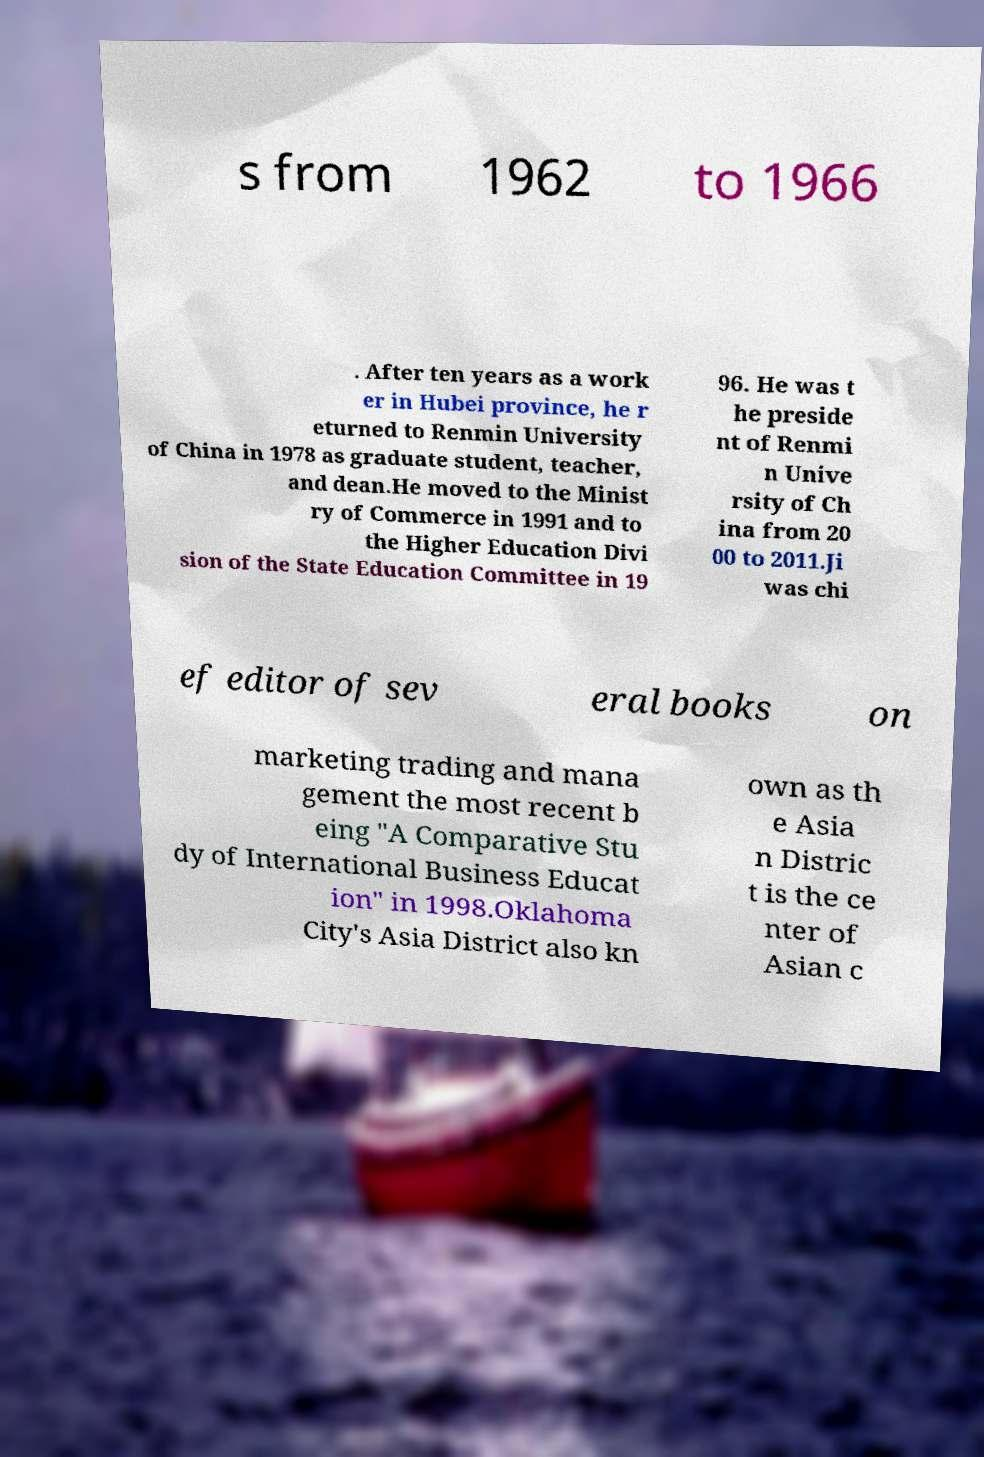Please read and relay the text visible in this image. What does it say? s from 1962 to 1966 . After ten years as a work er in Hubei province, he r eturned to Renmin University of China in 1978 as graduate student, teacher, and dean.He moved to the Minist ry of Commerce in 1991 and to the Higher Education Divi sion of the State Education Committee in 19 96. He was t he preside nt of Renmi n Unive rsity of Ch ina from 20 00 to 2011.Ji was chi ef editor of sev eral books on marketing trading and mana gement the most recent b eing "A Comparative Stu dy of International Business Educat ion" in 1998.Oklahoma City's Asia District also kn own as th e Asia n Distric t is the ce nter of Asian c 